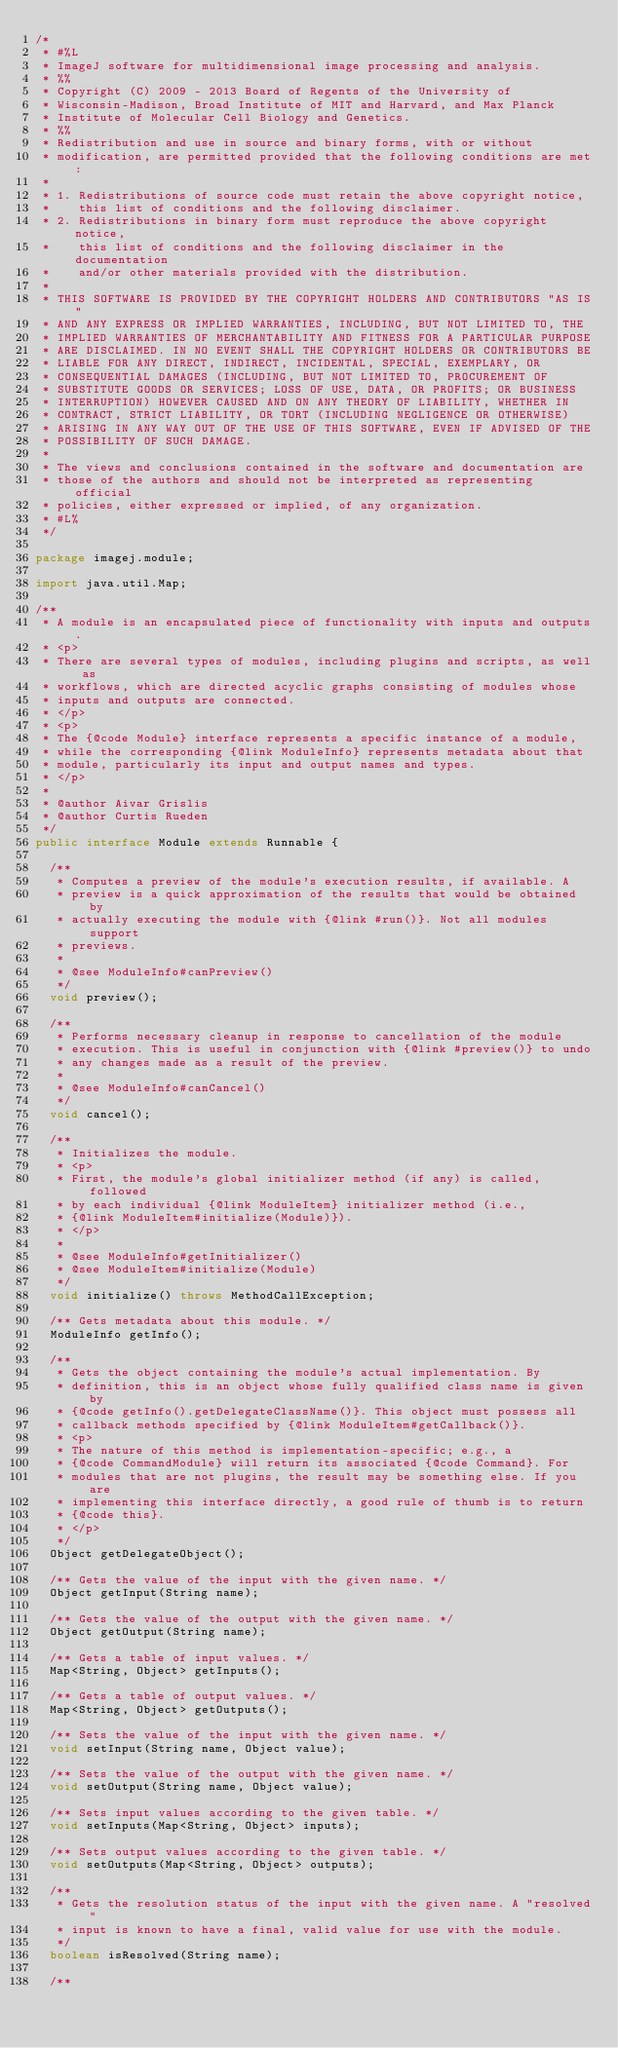<code> <loc_0><loc_0><loc_500><loc_500><_Java_>/*
 * #%L
 * ImageJ software for multidimensional image processing and analysis.
 * %%
 * Copyright (C) 2009 - 2013 Board of Regents of the University of
 * Wisconsin-Madison, Broad Institute of MIT and Harvard, and Max Planck
 * Institute of Molecular Cell Biology and Genetics.
 * %%
 * Redistribution and use in source and binary forms, with or without
 * modification, are permitted provided that the following conditions are met:
 * 
 * 1. Redistributions of source code must retain the above copyright notice,
 *    this list of conditions and the following disclaimer.
 * 2. Redistributions in binary form must reproduce the above copyright notice,
 *    this list of conditions and the following disclaimer in the documentation
 *    and/or other materials provided with the distribution.
 * 
 * THIS SOFTWARE IS PROVIDED BY THE COPYRIGHT HOLDERS AND CONTRIBUTORS "AS IS"
 * AND ANY EXPRESS OR IMPLIED WARRANTIES, INCLUDING, BUT NOT LIMITED TO, THE
 * IMPLIED WARRANTIES OF MERCHANTABILITY AND FITNESS FOR A PARTICULAR PURPOSE
 * ARE DISCLAIMED. IN NO EVENT SHALL THE COPYRIGHT HOLDERS OR CONTRIBUTORS BE
 * LIABLE FOR ANY DIRECT, INDIRECT, INCIDENTAL, SPECIAL, EXEMPLARY, OR
 * CONSEQUENTIAL DAMAGES (INCLUDING, BUT NOT LIMITED TO, PROCUREMENT OF
 * SUBSTITUTE GOODS OR SERVICES; LOSS OF USE, DATA, OR PROFITS; OR BUSINESS
 * INTERRUPTION) HOWEVER CAUSED AND ON ANY THEORY OF LIABILITY, WHETHER IN
 * CONTRACT, STRICT LIABILITY, OR TORT (INCLUDING NEGLIGENCE OR OTHERWISE)
 * ARISING IN ANY WAY OUT OF THE USE OF THIS SOFTWARE, EVEN IF ADVISED OF THE
 * POSSIBILITY OF SUCH DAMAGE.
 * 
 * The views and conclusions contained in the software and documentation are
 * those of the authors and should not be interpreted as representing official
 * policies, either expressed or implied, of any organization.
 * #L%
 */

package imagej.module;

import java.util.Map;

/**
 * A module is an encapsulated piece of functionality with inputs and outputs.
 * <p>
 * There are several types of modules, including plugins and scripts, as well as
 * workflows, which are directed acyclic graphs consisting of modules whose
 * inputs and outputs are connected.
 * </p>
 * <p>
 * The {@code Module} interface represents a specific instance of a module,
 * while the corresponding {@link ModuleInfo} represents metadata about that
 * module, particularly its input and output names and types.
 * </p>
 * 
 * @author Aivar Grislis
 * @author Curtis Rueden
 */
public interface Module extends Runnable {

	/**
	 * Computes a preview of the module's execution results, if available. A
	 * preview is a quick approximation of the results that would be obtained by
	 * actually executing the module with {@link #run()}. Not all modules support
	 * previews.
	 * 
	 * @see ModuleInfo#canPreview()
	 */
	void preview();

	/**
	 * Performs necessary cleanup in response to cancellation of the module
	 * execution. This is useful in conjunction with {@link #preview()} to undo
	 * any changes made as a result of the preview.
	 * 
	 * @see ModuleInfo#canCancel()
	 */
	void cancel();

	/**
	 * Initializes the module.
	 * <p>
	 * First, the module's global initializer method (if any) is called, followed
	 * by each individual {@link ModuleItem} initializer method (i.e.,
	 * {@link ModuleItem#initialize(Module)}).
	 * </p>
	 * 
	 * @see ModuleInfo#getInitializer()
	 * @see ModuleItem#initialize(Module)
	 */
	void initialize() throws MethodCallException;

	/** Gets metadata about this module. */
	ModuleInfo getInfo();

	/**
	 * Gets the object containing the module's actual implementation. By
	 * definition, this is an object whose fully qualified class name is given by
	 * {@code getInfo().getDelegateClassName()}. This object must possess all
	 * callback methods specified by {@link ModuleItem#getCallback()}.
	 * <p>
	 * The nature of this method is implementation-specific; e.g., a
	 * {@code CommandModule} will return its associated {@code Command}. For
	 * modules that are not plugins, the result may be something else. If you are
	 * implementing this interface directly, a good rule of thumb is to return
	 * {@code this}.
	 * </p>
	 */
	Object getDelegateObject();

	/** Gets the value of the input with the given name. */
	Object getInput(String name);

	/** Gets the value of the output with the given name. */
	Object getOutput(String name);

	/** Gets a table of input values. */
	Map<String, Object> getInputs();

	/** Gets a table of output values. */
	Map<String, Object> getOutputs();

	/** Sets the value of the input with the given name. */
	void setInput(String name, Object value);

	/** Sets the value of the output with the given name. */
	void setOutput(String name, Object value);

	/** Sets input values according to the given table. */
	void setInputs(Map<String, Object> inputs);

	/** Sets output values according to the given table. */
	void setOutputs(Map<String, Object> outputs);

	/**
	 * Gets the resolution status of the input with the given name. A "resolved"
	 * input is known to have a final, valid value for use with the module.
	 */
	boolean isResolved(String name);

	/**</code> 